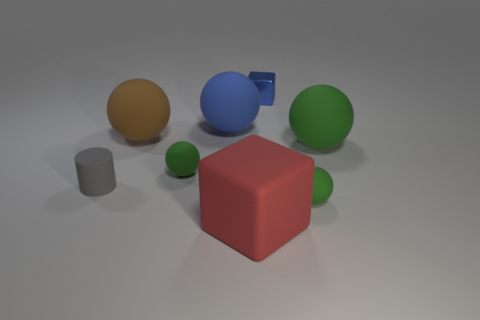There is a matte ball that is the same color as the shiny cube; what size is it?
Your answer should be compact. Large. Are there any blue cubes right of the large red rubber object?
Keep it short and to the point. Yes. There is a gray matte thing; what shape is it?
Provide a succinct answer. Cylinder. There is a large matte thing that is in front of the small sphere that is behind the tiny green matte sphere that is right of the blue shiny block; what is its shape?
Make the answer very short. Cube. What number of other objects are the same shape as the small shiny thing?
Your response must be concise. 1. There is a small green thing right of the blue sphere behind the small gray matte cylinder; what is it made of?
Ensure brevity in your answer.  Rubber. Are there any other things that have the same size as the blue ball?
Keep it short and to the point. Yes. Is the big blue ball made of the same material as the tiny green ball on the left side of the blue cube?
Your answer should be compact. Yes. What material is the green object that is on the left side of the large green ball and to the right of the blue ball?
Offer a terse response. Rubber. There is a large object that is right of the block that is in front of the large green matte object; what color is it?
Provide a short and direct response. Green. 